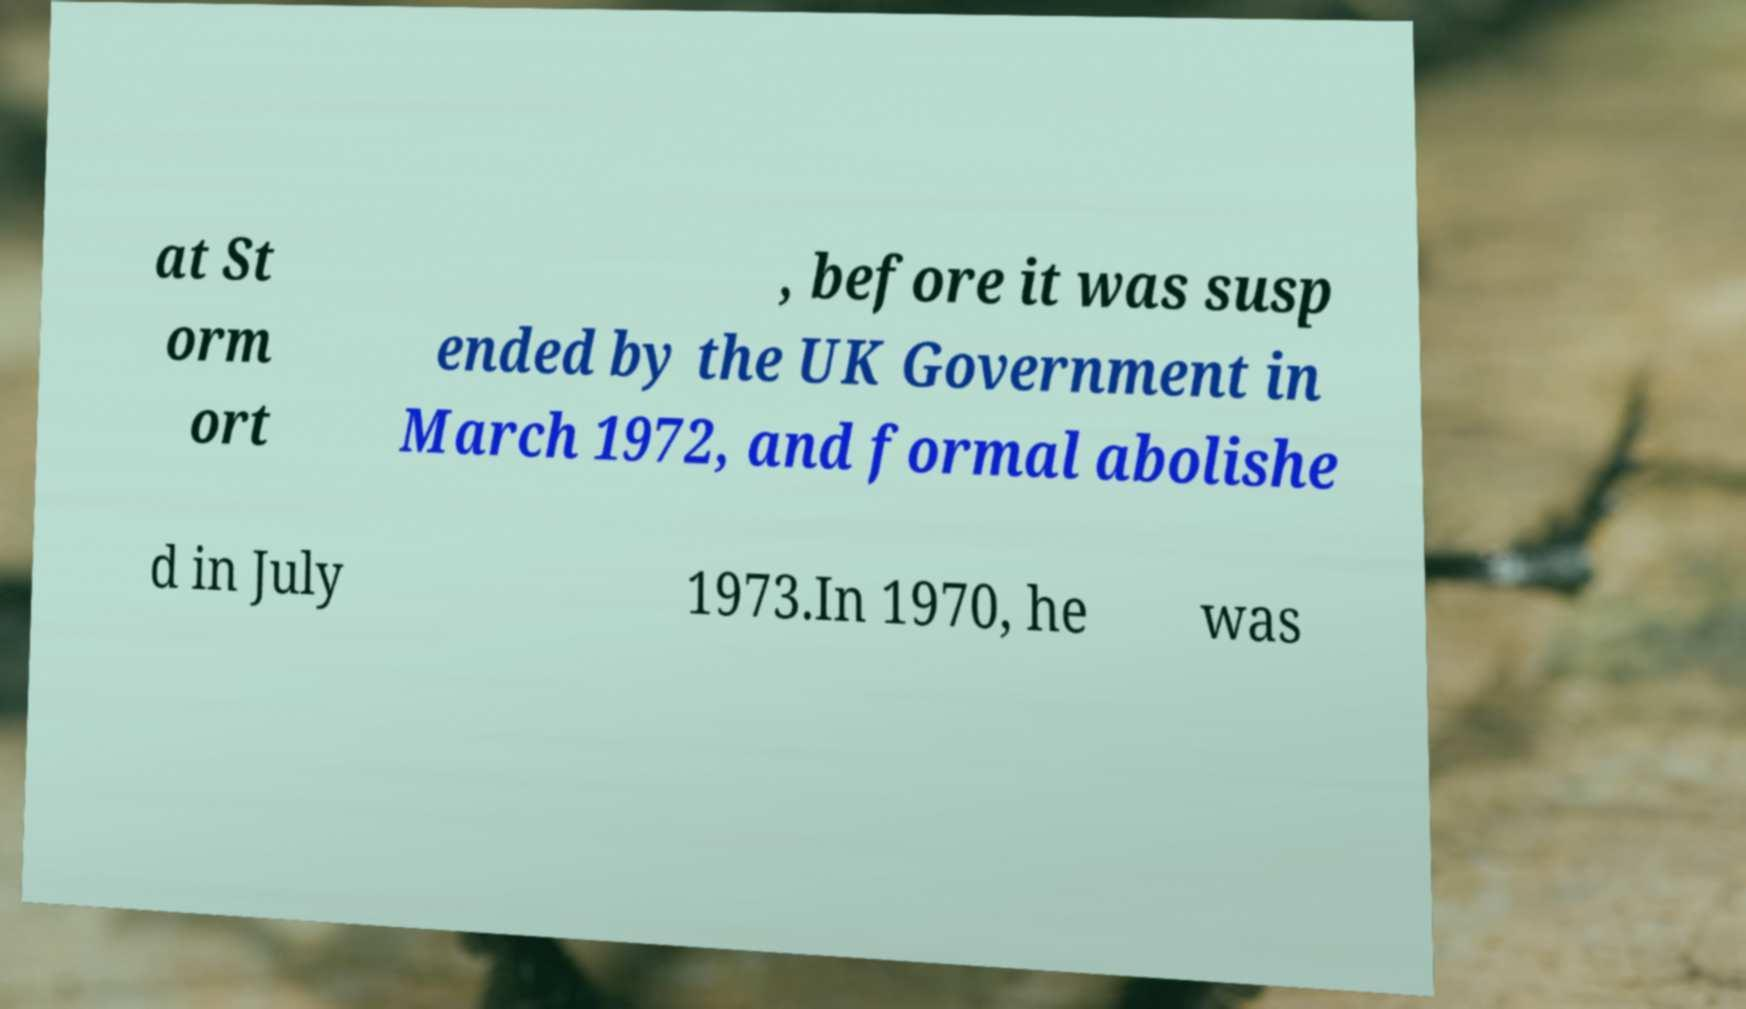Could you extract and type out the text from this image? at St orm ort , before it was susp ended by the UK Government in March 1972, and formal abolishe d in July 1973.In 1970, he was 